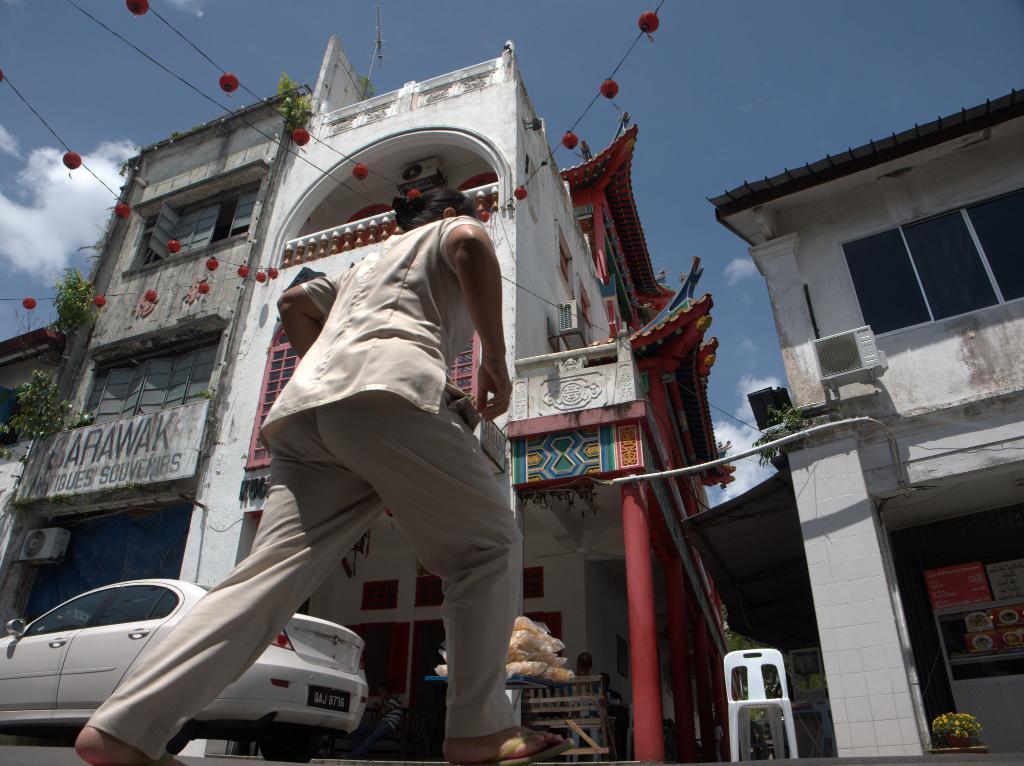How would you summarize this image in a sentence or two? In this image we can see a person is walking on the road and a vehicle is moving on the road. Here we can see a chair, wooden benches, flower pot, buildings, wire are the sky with clouds in the background. 